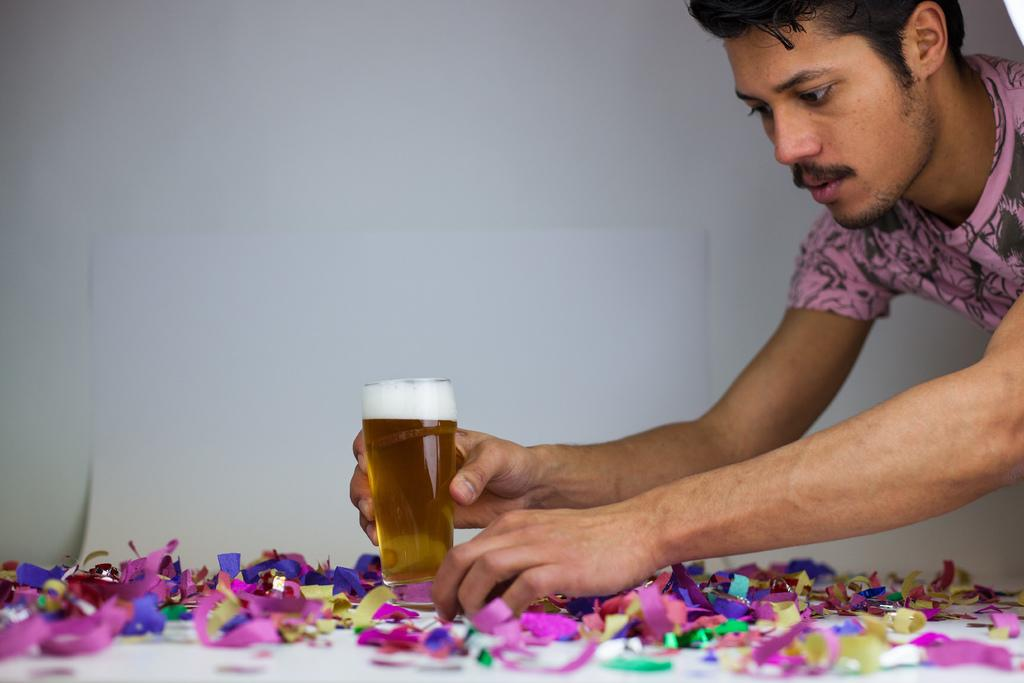Who is the main subject in the image? There is a man in the image. Where is the man located in the image? The man is on the left side of the image. What is the man holding in his hand? The man is holding a glass in his hand. What is the man trying to do with the glass? The man is trying to place the glass down. What type of wood can be seen in the image? There is no wood present in the image. Can you describe the ship that is sailing in the background of the image? There is no ship or background visible in the image; it only features a man holding a glass. 